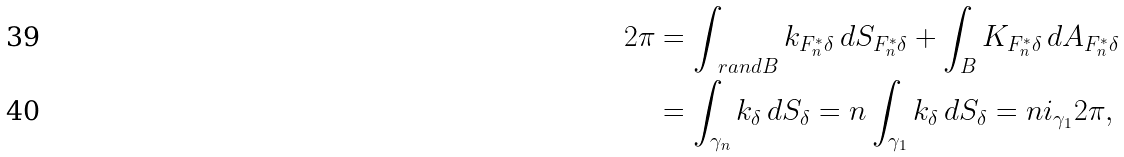<formula> <loc_0><loc_0><loc_500><loc_500>2 \pi & = \int _ { \ r a n d B } k _ { F _ { n } ^ { * } \delta } \, d S _ { F _ { n } ^ { * } \delta } + \int _ { B } K _ { F _ { n } ^ { * } \delta } \, d A _ { F _ { n } ^ { * } \delta } \\ & = \int _ { \gamma _ { n } } k _ { \delta } \, d S _ { \delta } = n \int _ { \gamma _ { 1 } } k _ { \delta } \, d S _ { \delta } = n i _ { \gamma _ { 1 } } 2 \pi ,</formula> 